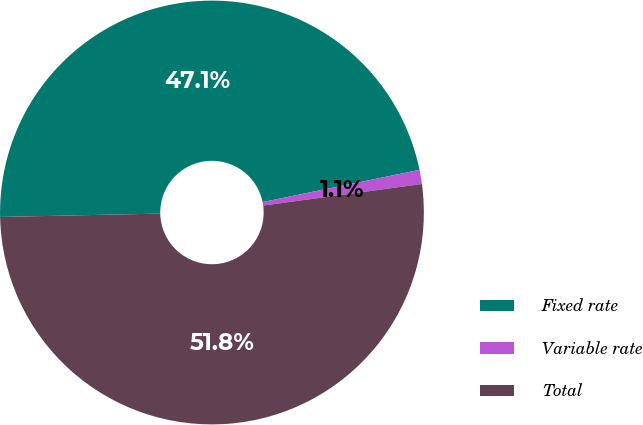Convert chart to OTSL. <chart><loc_0><loc_0><loc_500><loc_500><pie_chart><fcel>Fixed rate<fcel>Variable rate<fcel>Total<nl><fcel>47.11%<fcel>1.08%<fcel>51.82%<nl></chart> 